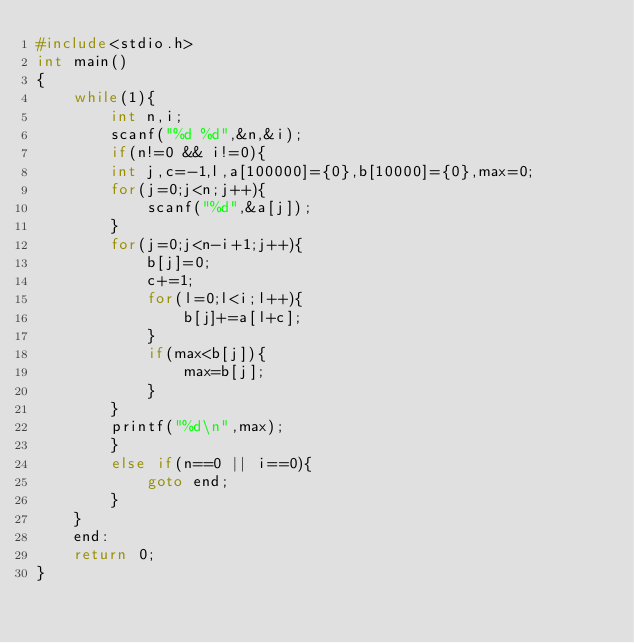Convert code to text. <code><loc_0><loc_0><loc_500><loc_500><_C_>#include<stdio.h>
int main()
{
	while(1){
		int n,i;
		scanf("%d %d",&n,&i);
		if(n!=0 && i!=0){
		int j,c=-1,l,a[100000]={0},b[10000]={0},max=0;
		for(j=0;j<n;j++){
			scanf("%d",&a[j]);
		}
		for(j=0;j<n-i+1;j++){
			b[j]=0;
			c+=1;
			for(l=0;l<i;l++){
				b[j]+=a[l+c];
			}
			if(max<b[j]){
				max=b[j];
			}
		}
		printf("%d\n",max);
		}
		else if(n==0 || i==0){
			goto end;
		}
	}
	end:
	return 0;
}
</code> 